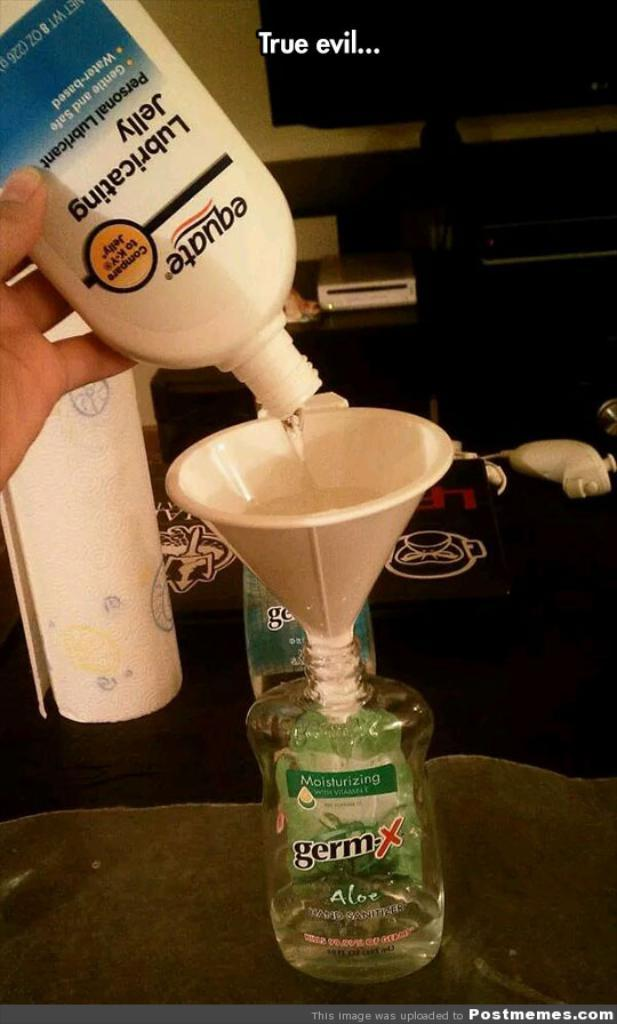<image>
Summarize the visual content of the image. Someone is refilleing a GermX bottle with lube. 